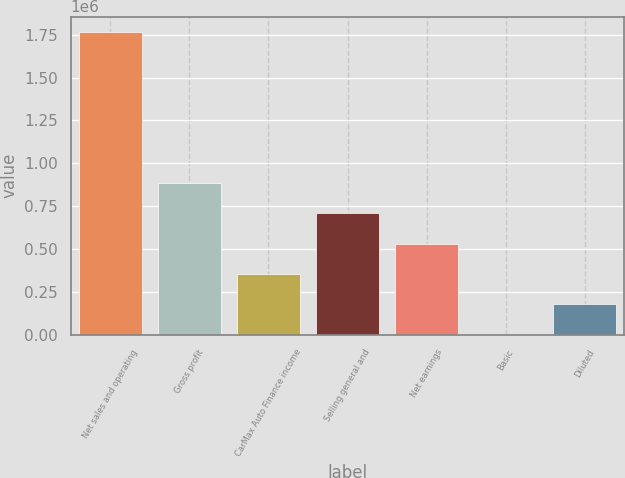<chart> <loc_0><loc_0><loc_500><loc_500><bar_chart><fcel>Net sales and operating<fcel>Gross profit<fcel>CarMax Auto Finance income<fcel>Selling general and<fcel>Net earnings<fcel>Basic<fcel>Diluted<nl><fcel>1.76815e+06<fcel>884074<fcel>353630<fcel>707259<fcel>530444<fcel>0.21<fcel>176815<nl></chart> 